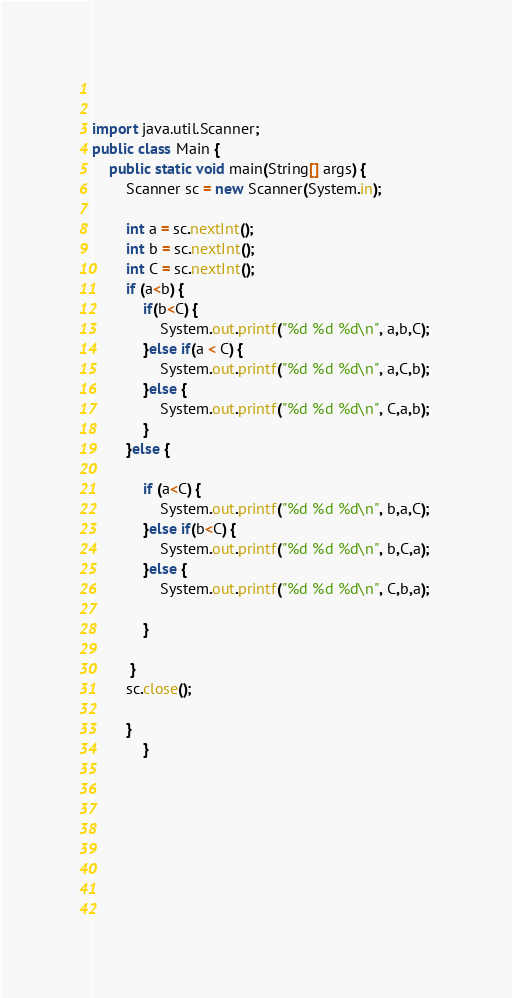<code> <loc_0><loc_0><loc_500><loc_500><_Java_>                  
                
import java.util.Scanner;
public class Main {
    public static void main(String[] args) {
        Scanner sc = new Scanner(System.in);

        int a = sc.nextInt();
        int b = sc.nextInt();
        int C = sc.nextInt();
        if (a<b) {
            if(b<C) {
                System.out.printf("%d %d %d\n", a,b,C);
            }else if(a < C) {
                System.out.printf("%d %d %d\n", a,C,b);
            }else {
                System.out.printf("%d %d %d\n", C,a,b); 
            }
        }else {
            
            if (a<C) {
                System.out.printf("%d %d %d\n", b,a,C);
            }else if(b<C) {
                System.out.printf("%d %d %d\n", b,C,a);
            }else {
                System.out.printf("%d %d %d\n", C,b,a);
                
            }                

         }
        sc.close();    

        }
            }

            


    

    
    
</code> 